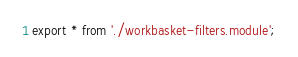<code> <loc_0><loc_0><loc_500><loc_500><_TypeScript_>export * from './workbasket-filters.module';
</code> 